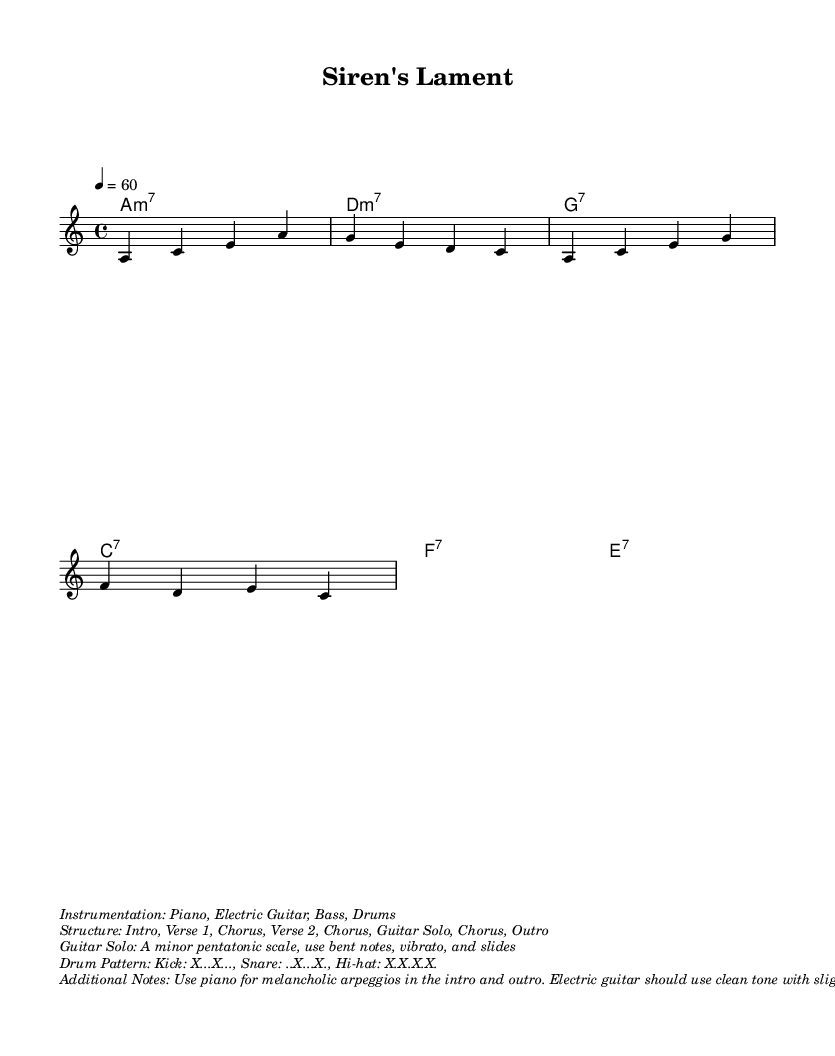What is the key signature of this music? The key signature is indicated with the letter "a" being directly associated with the chord mode and corresponds to A minor, which has no sharps or flats.
Answer: A minor What is the time signature of this piece? The time signature is denoted at the beginning of the sheet music as 4/4, indicating four beats per measure and a quarter note receives one beat.
Answer: 4/4 What is the tempo marking of the composition? The tempo marking is explicitly stated and shows "4 = 60," which means there are 60 beats per minute, suggesting a slower pace.
Answer: 60 How many measures does the verse structure have? The structure includes "Verse 1" and "Verse 2," each notated as part of the music layout, indicating that there are two verses within the entire composition.
Answer: Two What types of instruments are indicated for this piece? The instrumentation is described in the markup section and lists the instruments to be used, including piano, electric guitar, bass, and drums.
Answer: Piano, Electric Guitar, Bass, Drums What scale should be used for the guitar solo? The guitar solo section specifies using the A minor pentatonic scale, which is a five-note scale derived from the A minor scale commonly used in blues guitar solos.
Answer: A minor pentatonic scale What kind of tone should the electric guitar use in the verses? The additional notes prescribe that the electric guitar should use a clean tone with slight reverb during the verses, which helps to create a melancholic sound characteristic of the blues genre.
Answer: Clean tone with slight reverb 